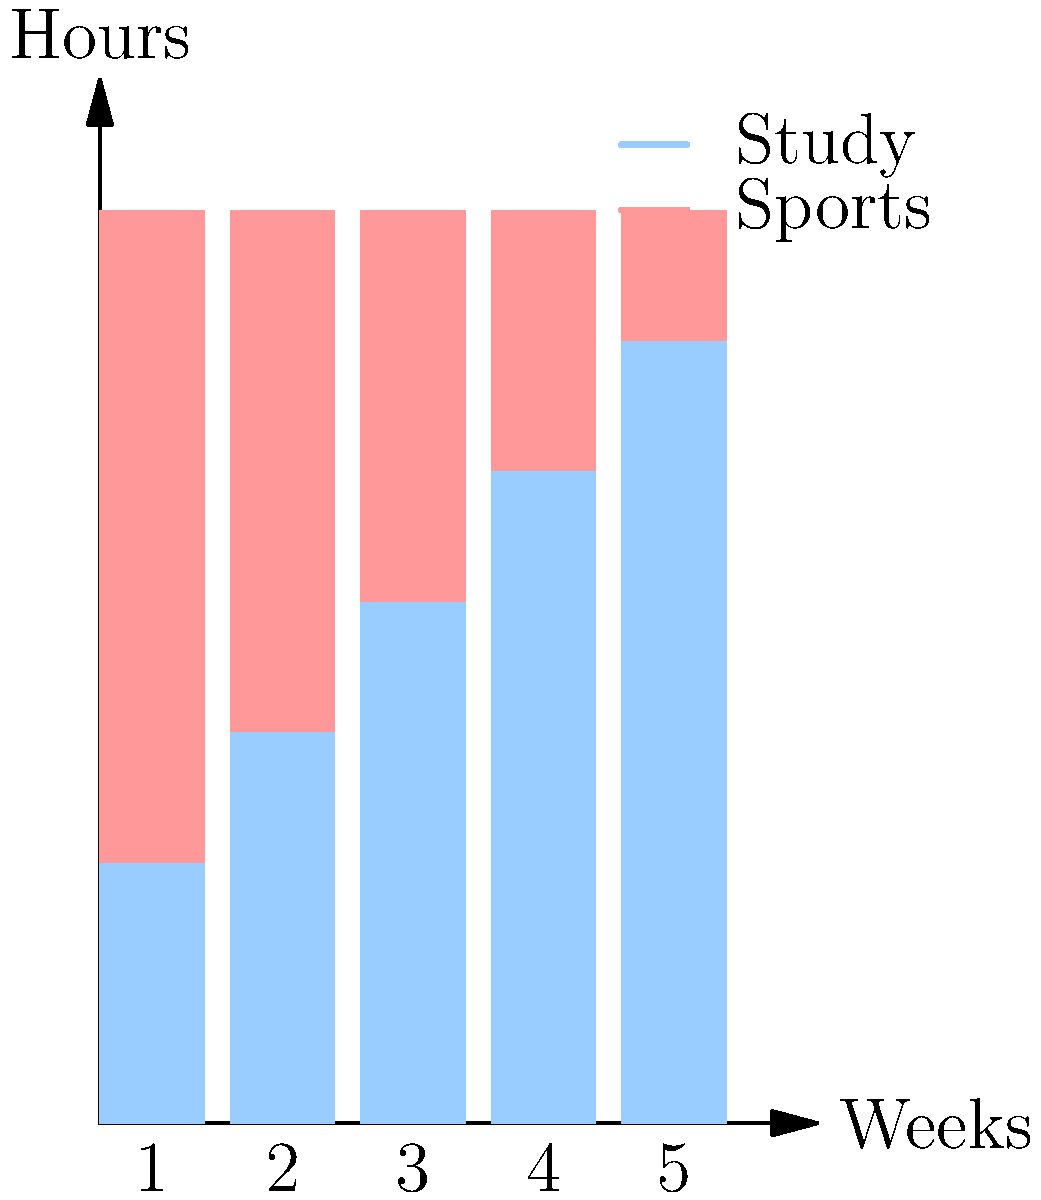The stacked bar chart shows the distribution of hours spent on studying and sports activities over five weeks. In which week did the student achieve the best balance between study time and sports activities, where the difference between the two was smallest? To find the week with the best balance between study time and sports activities, we need to calculate the difference between study and sports hours for each week and find the smallest difference:

Week 1: Study = 2 hours, Sports = 5 hours
Difference = |2 - 5| = 3 hours

Week 2: Study = 3 hours, Sports = 4 hours
Difference = |3 - 4| = 1 hour

Week 3: Study = 4 hours, Sports = 3 hours
Difference = |4 - 3| = 1 hour

Week 4: Study = 5 hours, Sports = 2 hours
Difference = |5 - 2| = 3 hours

Week 5: Study = 6 hours, Sports = 1 hour
Difference = |6 - 1| = 5 hours

The smallest difference is 1 hour, which occurs in both Week 2 and Week 3. However, Week 3 shows a slight advantage in study time (4 hours) compared to sports time (3 hours), which might be preferable for a concerned parent.
Answer: Week 3 